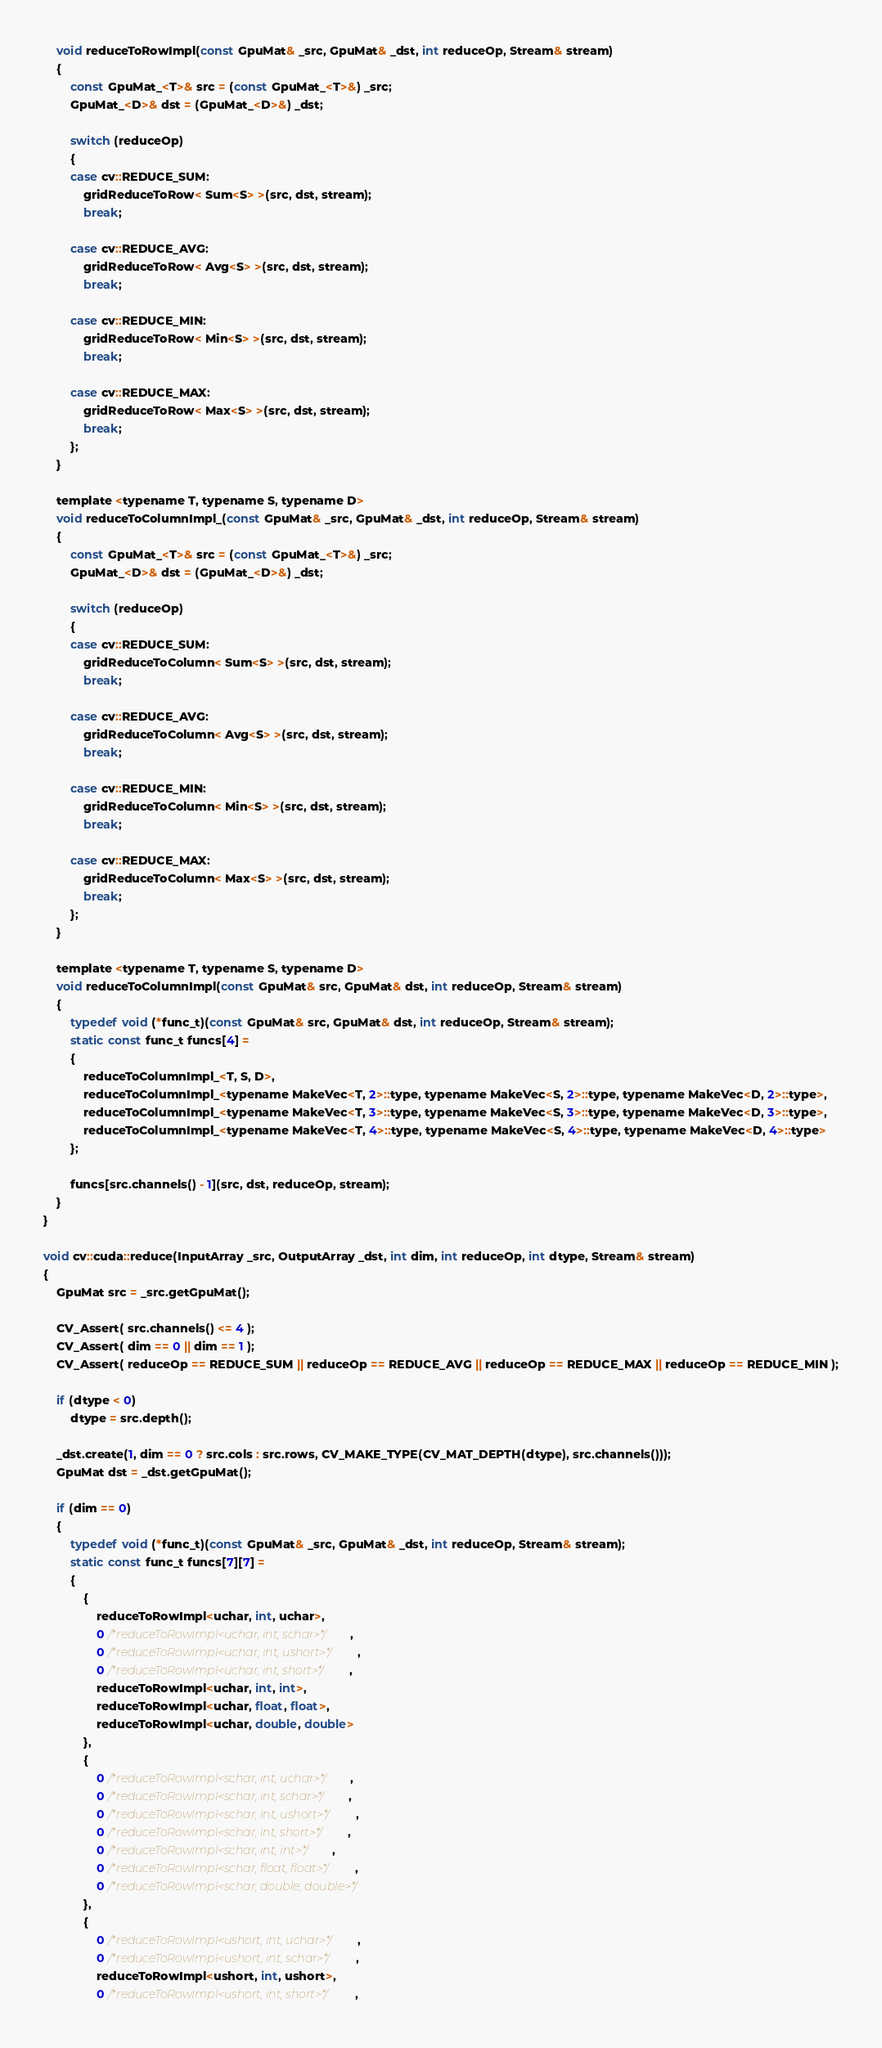Convert code to text. <code><loc_0><loc_0><loc_500><loc_500><_Cuda_>    void reduceToRowImpl(const GpuMat& _src, GpuMat& _dst, int reduceOp, Stream& stream)
    {
        const GpuMat_<T>& src = (const GpuMat_<T>&) _src;
        GpuMat_<D>& dst = (GpuMat_<D>&) _dst;

        switch (reduceOp)
        {
        case cv::REDUCE_SUM:
            gridReduceToRow< Sum<S> >(src, dst, stream);
            break;

        case cv::REDUCE_AVG:
            gridReduceToRow< Avg<S> >(src, dst, stream);
            break;

        case cv::REDUCE_MIN:
            gridReduceToRow< Min<S> >(src, dst, stream);
            break;

        case cv::REDUCE_MAX:
            gridReduceToRow< Max<S> >(src, dst, stream);
            break;
        };
    }

    template <typename T, typename S, typename D>
    void reduceToColumnImpl_(const GpuMat& _src, GpuMat& _dst, int reduceOp, Stream& stream)
    {
        const GpuMat_<T>& src = (const GpuMat_<T>&) _src;
        GpuMat_<D>& dst = (GpuMat_<D>&) _dst;

        switch (reduceOp)
        {
        case cv::REDUCE_SUM:
            gridReduceToColumn< Sum<S> >(src, dst, stream);
            break;

        case cv::REDUCE_AVG:
            gridReduceToColumn< Avg<S> >(src, dst, stream);
            break;

        case cv::REDUCE_MIN:
            gridReduceToColumn< Min<S> >(src, dst, stream);
            break;

        case cv::REDUCE_MAX:
            gridReduceToColumn< Max<S> >(src, dst, stream);
            break;
        };
    }

    template <typename T, typename S, typename D>
    void reduceToColumnImpl(const GpuMat& src, GpuMat& dst, int reduceOp, Stream& stream)
    {
        typedef void (*func_t)(const GpuMat& src, GpuMat& dst, int reduceOp, Stream& stream);
        static const func_t funcs[4] =
        {
            reduceToColumnImpl_<T, S, D>,
            reduceToColumnImpl_<typename MakeVec<T, 2>::type, typename MakeVec<S, 2>::type, typename MakeVec<D, 2>::type>,
            reduceToColumnImpl_<typename MakeVec<T, 3>::type, typename MakeVec<S, 3>::type, typename MakeVec<D, 3>::type>,
            reduceToColumnImpl_<typename MakeVec<T, 4>::type, typename MakeVec<S, 4>::type, typename MakeVec<D, 4>::type>
        };

        funcs[src.channels() - 1](src, dst, reduceOp, stream);
    }
}

void cv::cuda::reduce(InputArray _src, OutputArray _dst, int dim, int reduceOp, int dtype, Stream& stream)
{
    GpuMat src = _src.getGpuMat();

    CV_Assert( src.channels() <= 4 );
    CV_Assert( dim == 0 || dim == 1 );
    CV_Assert( reduceOp == REDUCE_SUM || reduceOp == REDUCE_AVG || reduceOp == REDUCE_MAX || reduceOp == REDUCE_MIN );

    if (dtype < 0)
        dtype = src.depth();

    _dst.create(1, dim == 0 ? src.cols : src.rows, CV_MAKE_TYPE(CV_MAT_DEPTH(dtype), src.channels()));
    GpuMat dst = _dst.getGpuMat();

    if (dim == 0)
    {
        typedef void (*func_t)(const GpuMat& _src, GpuMat& _dst, int reduceOp, Stream& stream);
        static const func_t funcs[7][7] =
        {
            {
                reduceToRowImpl<uchar, int, uchar>,
                0 /*reduceToRowImpl<uchar, int, schar>*/,
                0 /*reduceToRowImpl<uchar, int, ushort>*/,
                0 /*reduceToRowImpl<uchar, int, short>*/,
                reduceToRowImpl<uchar, int, int>,
                reduceToRowImpl<uchar, float, float>,
                reduceToRowImpl<uchar, double, double>
            },
            {
                0 /*reduceToRowImpl<schar, int, uchar>*/,
                0 /*reduceToRowImpl<schar, int, schar>*/,
                0 /*reduceToRowImpl<schar, int, ushort>*/,
                0 /*reduceToRowImpl<schar, int, short>*/,
                0 /*reduceToRowImpl<schar, int, int>*/,
                0 /*reduceToRowImpl<schar, float, float>*/,
                0 /*reduceToRowImpl<schar, double, double>*/
            },
            {
                0 /*reduceToRowImpl<ushort, int, uchar>*/,
                0 /*reduceToRowImpl<ushort, int, schar>*/,
                reduceToRowImpl<ushort, int, ushort>,
                0 /*reduceToRowImpl<ushort, int, short>*/,</code> 